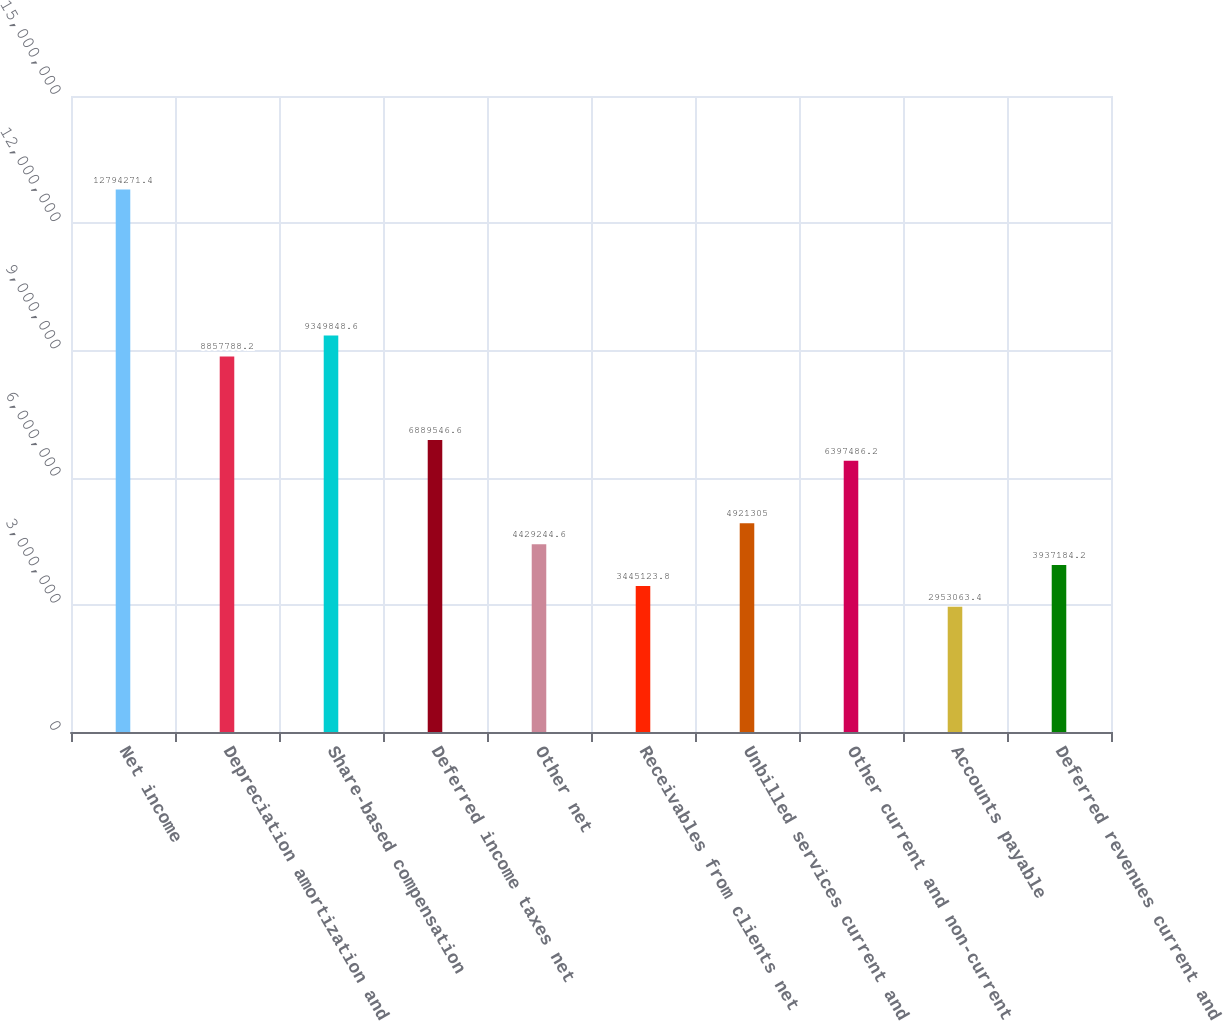<chart> <loc_0><loc_0><loc_500><loc_500><bar_chart><fcel>Net income<fcel>Depreciation amortization and<fcel>Share-based compensation<fcel>Deferred income taxes net<fcel>Other net<fcel>Receivables from clients net<fcel>Unbilled services current and<fcel>Other current and non-current<fcel>Accounts payable<fcel>Deferred revenues current and<nl><fcel>1.27943e+07<fcel>8.85779e+06<fcel>9.34985e+06<fcel>6.88955e+06<fcel>4.42924e+06<fcel>3.44512e+06<fcel>4.9213e+06<fcel>6.39749e+06<fcel>2.95306e+06<fcel>3.93718e+06<nl></chart> 